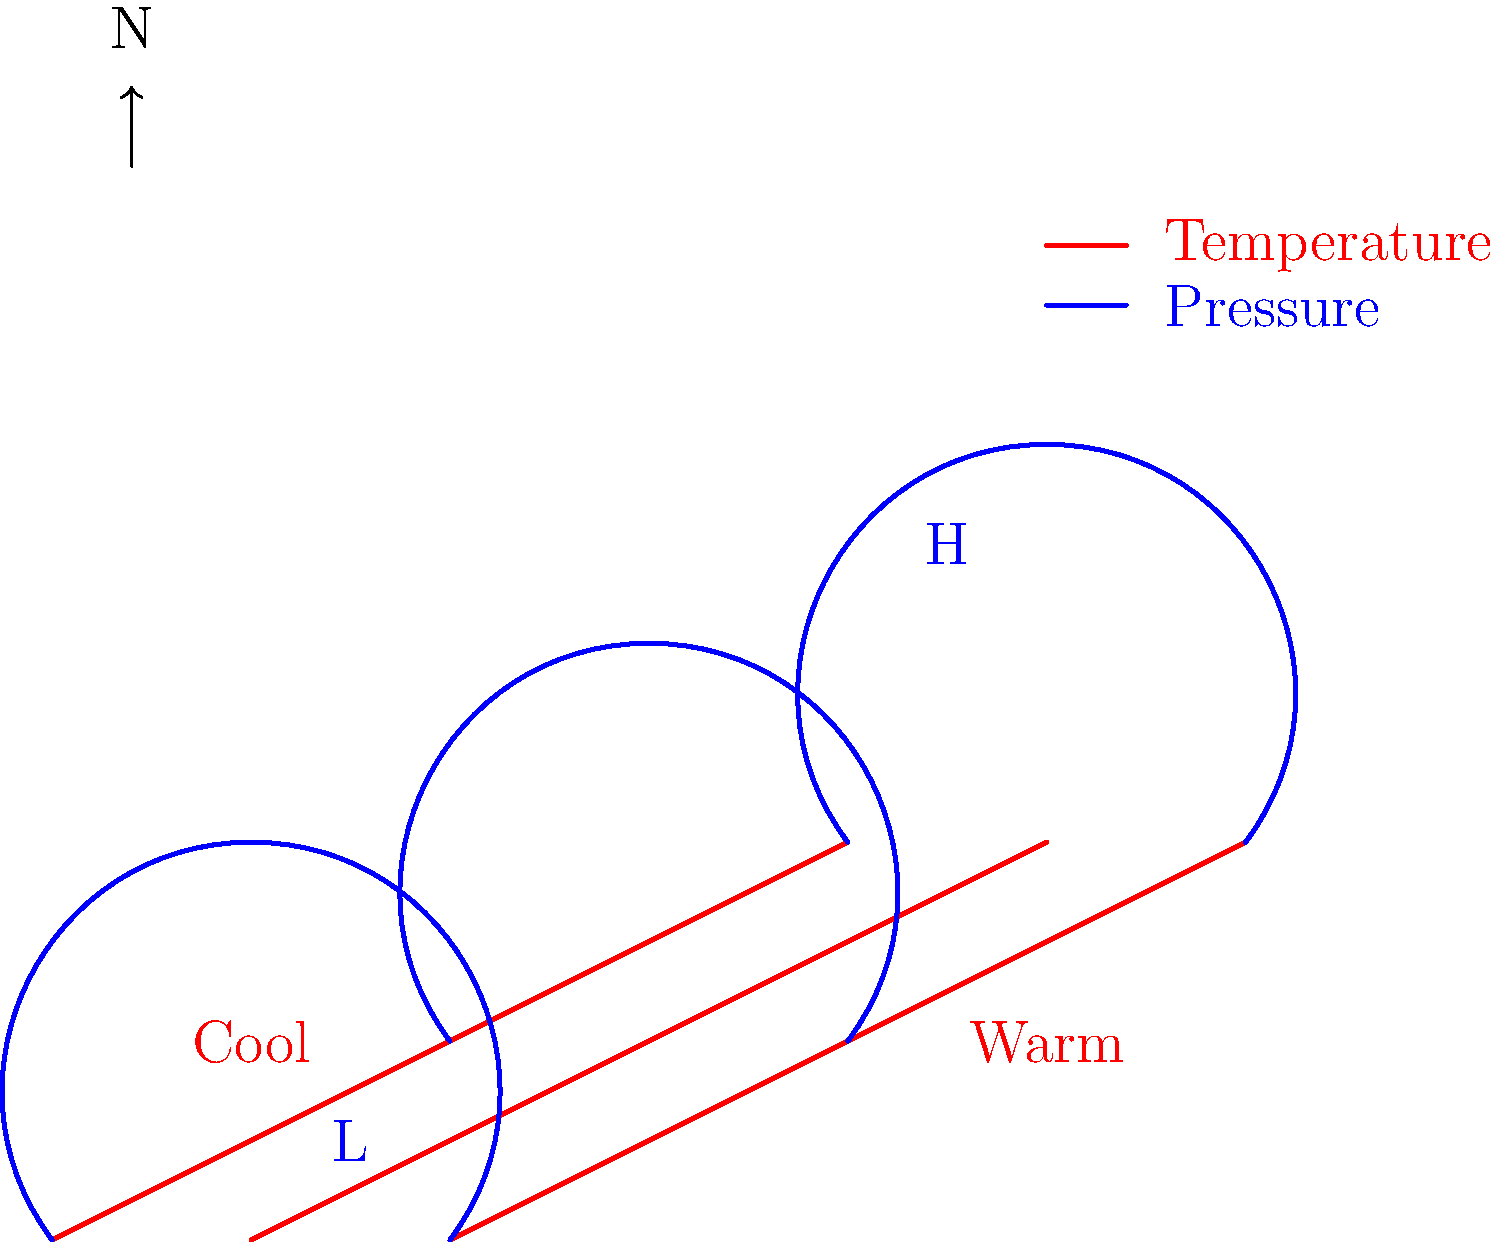Based on the temperature and pressure map provided, what type of weather system is likely approaching, and how might it affect local weather conditions? To analyze this map and predict the weather, we need to follow these steps:

1. Identify pressure systems:
   - There's a high-pressure system (H) in the upper right quadrant
   - A low-pressure system (L) is present in the lower left quadrant

2. Analyze temperature gradients:
   - Warmer temperatures are observed on the right side
   - Cooler temperatures are on the left side

3. Interpret the relationship between pressure and temperature:
   - The warm air is associated with the high-pressure system
   - The cool air is associated with the low-pressure system

4. Consider air movement:
   - Air flows from high to low pressure
   - This creates a clockwise rotation around the high-pressure system in the Northern Hemisphere

5. Predict weather patterns:
   - The approaching system is likely a warm front
   - As the warm air (associated with high pressure) moves towards the cool air (associated with low pressure), it will rise over the cooler air

6. Forecast local weather conditions:
   - Increasing cloudiness as the warm front approaches
   - Possible light precipitation as the warm air rises and cools
   - Gradual warming of temperatures
   - Wind direction shifting, likely from southeast to southwest

This analysis suggests an approaching warm front, which typically brings a gradual change in weather conditions, including increasing cloudiness, potential light precipitation, and warming temperatures.
Answer: Approaching warm front; increasing cloudiness, possible light precipitation, and gradual warming 